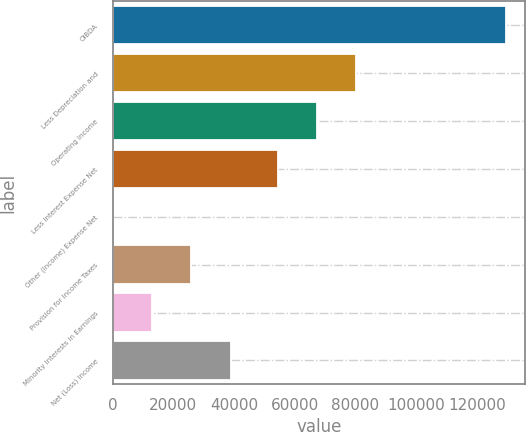<chart> <loc_0><loc_0><loc_500><loc_500><bar_chart><fcel>OIBDA<fcel>Less Depreciation and<fcel>Operating Income<fcel>Less Interest Expense Net<fcel>Other (Income) Expense Net<fcel>Provision for Income Taxes<fcel>Minority Interests in Earnings<fcel>Net (Loss) Income<nl><fcel>129463<fcel>80314.2<fcel>67369.6<fcel>54425<fcel>17<fcel>25906.2<fcel>12961.6<fcel>38850.8<nl></chart> 